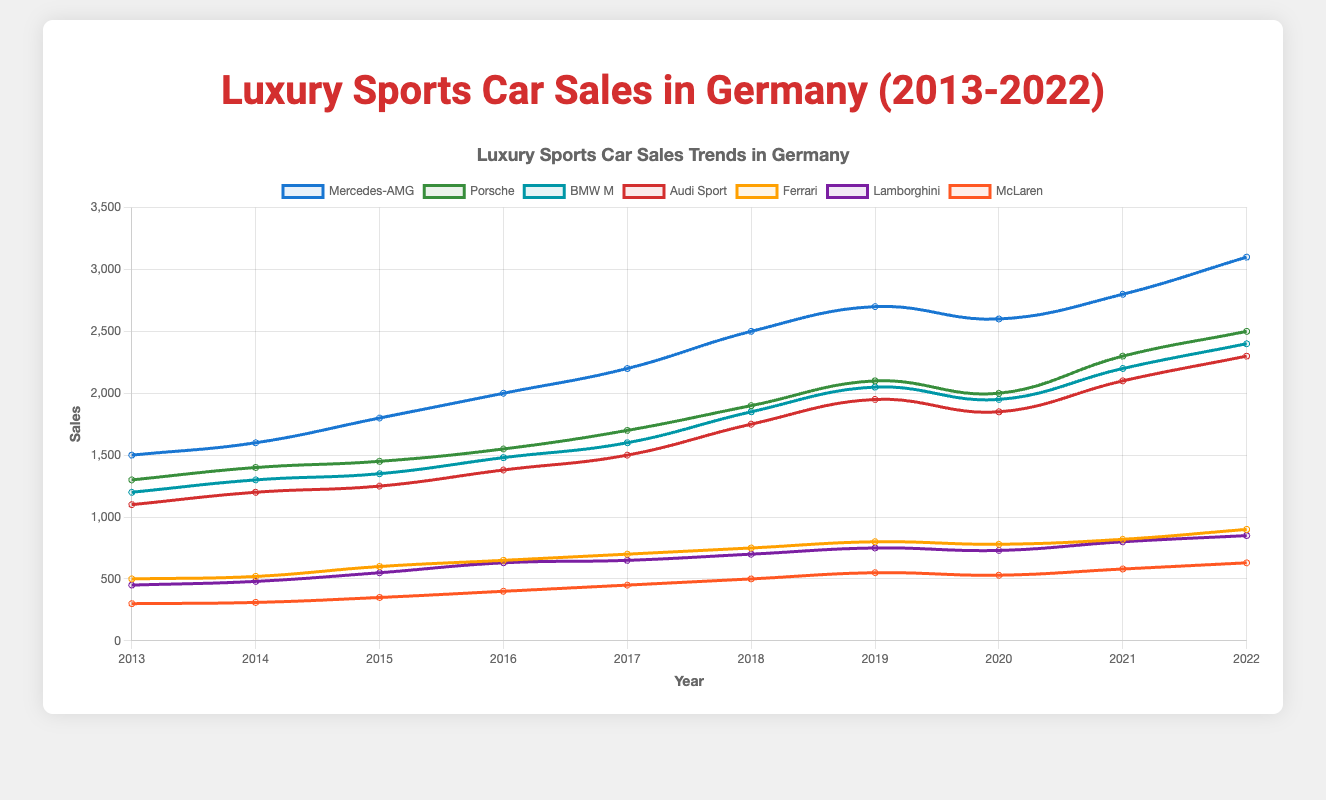Which brand had the highest sales in 2022? Checking the end of the lines in the figure for 2022, Mercedes-AMG has the highest point with 3100 sales.
Answer: Mercedes-AMG How did the sales of Porsche change from 2019 to 2020? Observing the point for Porsche from 2019 to 2020, the sales decreased from 2100 to 2000, showing a decline.
Answer: Decreased Which brand showed the most consistent sales increase from 2013 to 2022? Evaluating the lines for steady inclines, Mercedes-AMG shows a consistent increase each year from 1500 in 2013 to 3100 in 2022.
Answer: Mercedes-AMG What was the total sales for Audi Sport over the last decade? Summing the sales values for Audi Sport: 1100 + 1200 + 1250 + 1380 + 1500 + 1750 + 1950 + 1850 + 2100 + 2300 gives a total of 16,380.
Answer: 16,380 Which two brands had the closest sales figures in 2022, and what were the amounts? Looking at the 2022 values, Audi Sport (2300) and BMW M (2400) had the closest figures.
Answer: Audi Sport (2300) and BMW M (2400) Between 2016 and 2018, which brand saw the largest sales increase? Calculating the difference in sales for each brand between 2016 and 2018, Mercedes-AMG increased from 2000 to 2500 (500 units), which is the largest increase.
Answer: Mercedes-AMG In which year did Ferrari surpass Lamborghini in sales for the first time? Checking the lines for Ferrari and Lamborghini, Ferrari first surpasses Lamborghini in sales in 2022, with 900 vs. 850 sales.
Answer: 2022 Comparing BMW M and Audi Sport, which brand had higher sales in 2019 and by how much? In 2019, BMW M had 2050 sales and Audi Sport had 1950 sales, so BMW M had 100 more sales.
Answer: BMW M, 100 more What was the average annual sales of McLaren over the decade? Summing the sales of McLaren (300 + 310 + 350 + 400 + 450 + 500 + 550 + 530 + 580 + 630) equals 4600. Dividing by 10 gives an average of 460.
Answer: 460 From 2013 to 2022, how many brands experienced a decrease in sales at least once? Checking each brand's line, all brands (Mercedes-AMG, Porsche, BMW M, Audi Sport, Ferrari, Lamborghini, McLaren) experienced at least one decrease in sales at some point.
Answer: 7 brands 